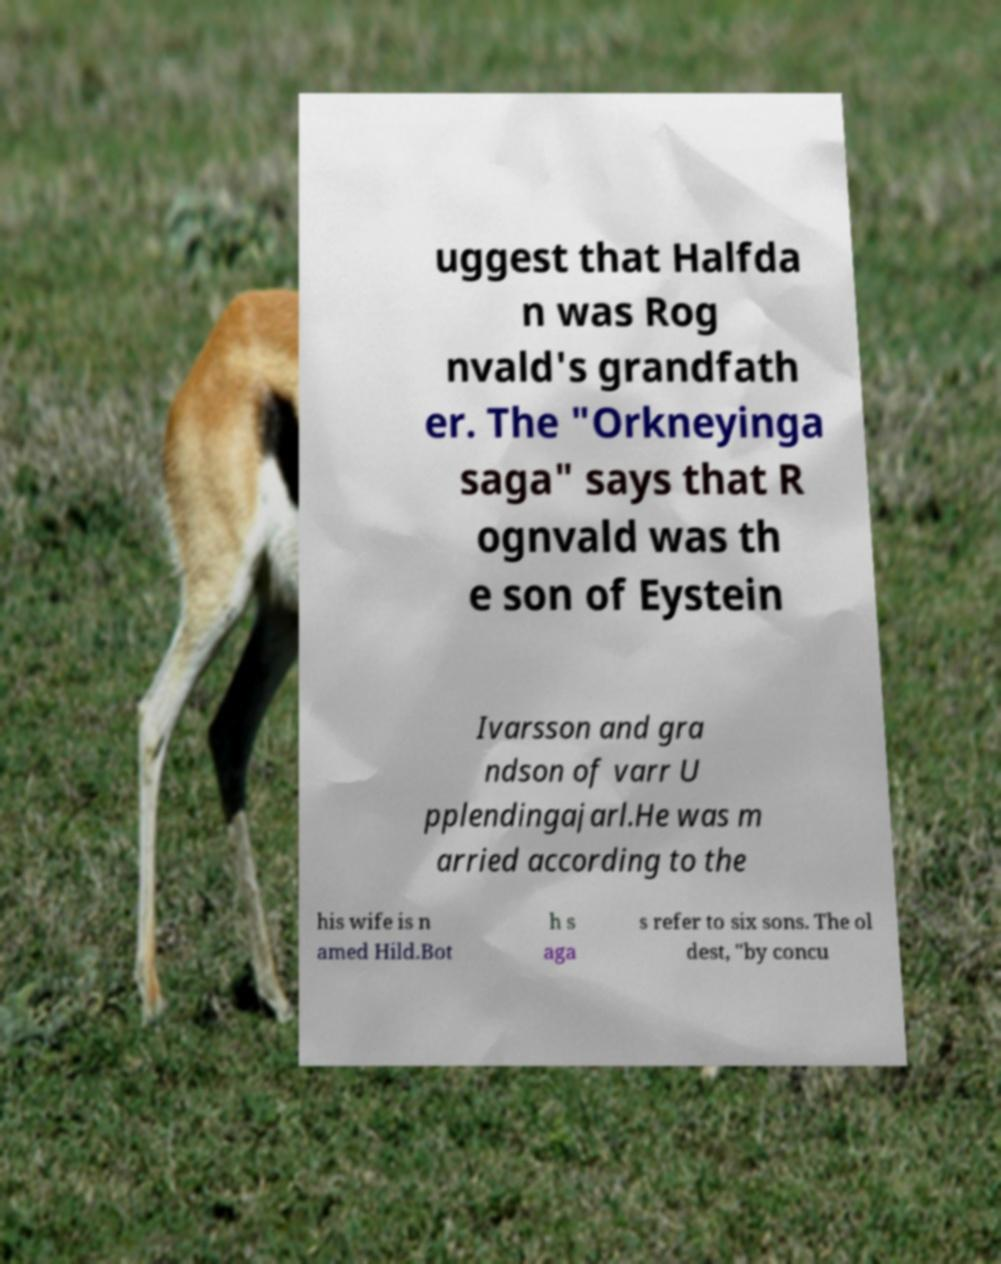For documentation purposes, I need the text within this image transcribed. Could you provide that? uggest that Halfda n was Rog nvald's grandfath er. The "Orkneyinga saga" says that R ognvald was th e son of Eystein Ivarsson and gra ndson of varr U pplendingajarl.He was m arried according to the his wife is n amed Hild.Bot h s aga s refer to six sons. The ol dest, "by concu 